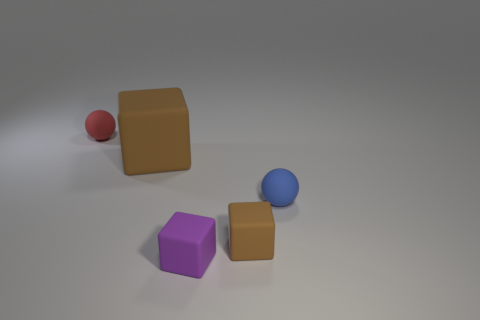Subtract all brown cubes. How many were subtracted if there are1brown cubes left? 1 Add 1 small purple rubber cylinders. How many objects exist? 6 Subtract all balls. How many objects are left? 3 Subtract 0 gray cylinders. How many objects are left? 5 Subtract all large gray rubber cylinders. Subtract all large rubber blocks. How many objects are left? 4 Add 5 small brown matte blocks. How many small brown matte blocks are left? 6 Add 4 blue matte balls. How many blue matte balls exist? 5 